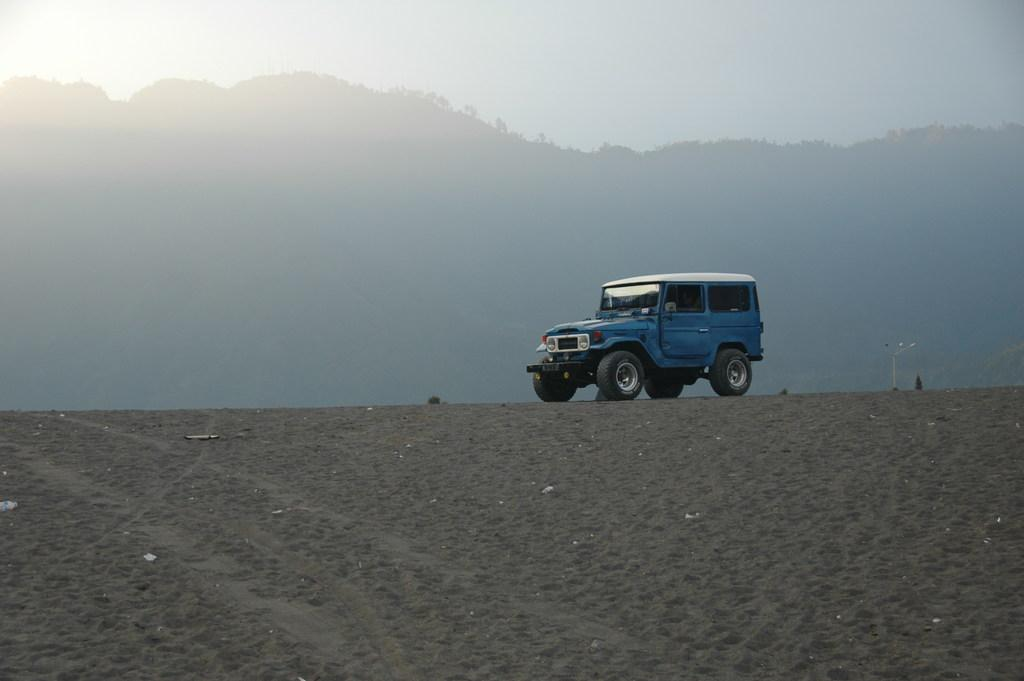What type of vehicle is on the ground in the image? There is a blue color jeep on the ground. What can be seen in the background of the image? There are plants and trees on the mountain in the background, and the sky is also visible. Where are the dolls playing during recess in the image? There are no dolls or recess present in the image. 